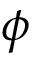Convert formula to latex. <formula><loc_0><loc_0><loc_500><loc_500>\phi</formula> 